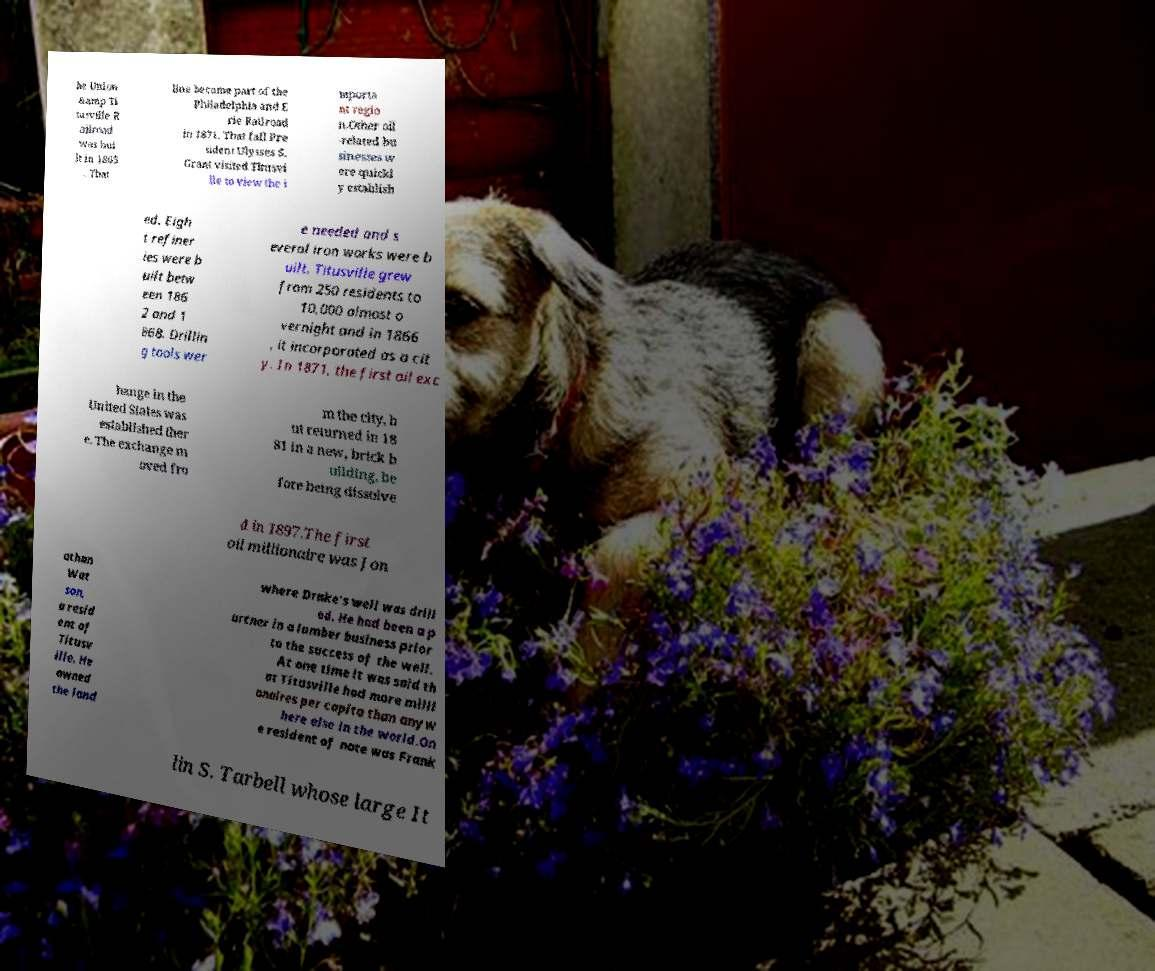I need the written content from this picture converted into text. Can you do that? he Union &amp Ti tusville R ailroad was bui lt in 1865 . That line became part of the Philadelphia and E rie Railroad in 1871. That fall Pre sident Ulysses S. Grant visited Titusvi lle to view the i mporta nt regio n.Other oil -related bu sinesses w ere quickl y establish ed. Eigh t refiner ies were b uilt betw een 186 2 and 1 868. Drillin g tools wer e needed and s everal iron works were b uilt. Titusville grew from 250 residents to 10,000 almost o vernight and in 1866 , it incorporated as a cit y. In 1871, the first oil exc hange in the United States was established ther e. The exchange m oved fro m the city, b ut returned in 18 81 in a new, brick b uilding, be fore being dissolve d in 1897.The first oil millionaire was Jon athan Wat son, a resid ent of Titusv ille. He owned the land where Drake's well was drill ed. He had been a p artner in a lumber business prior to the success of the well. At one time it was said th at Titusville had more milli onaires per capita than anyw here else in the world.On e resident of note was Frank lin S. Tarbell whose large It 